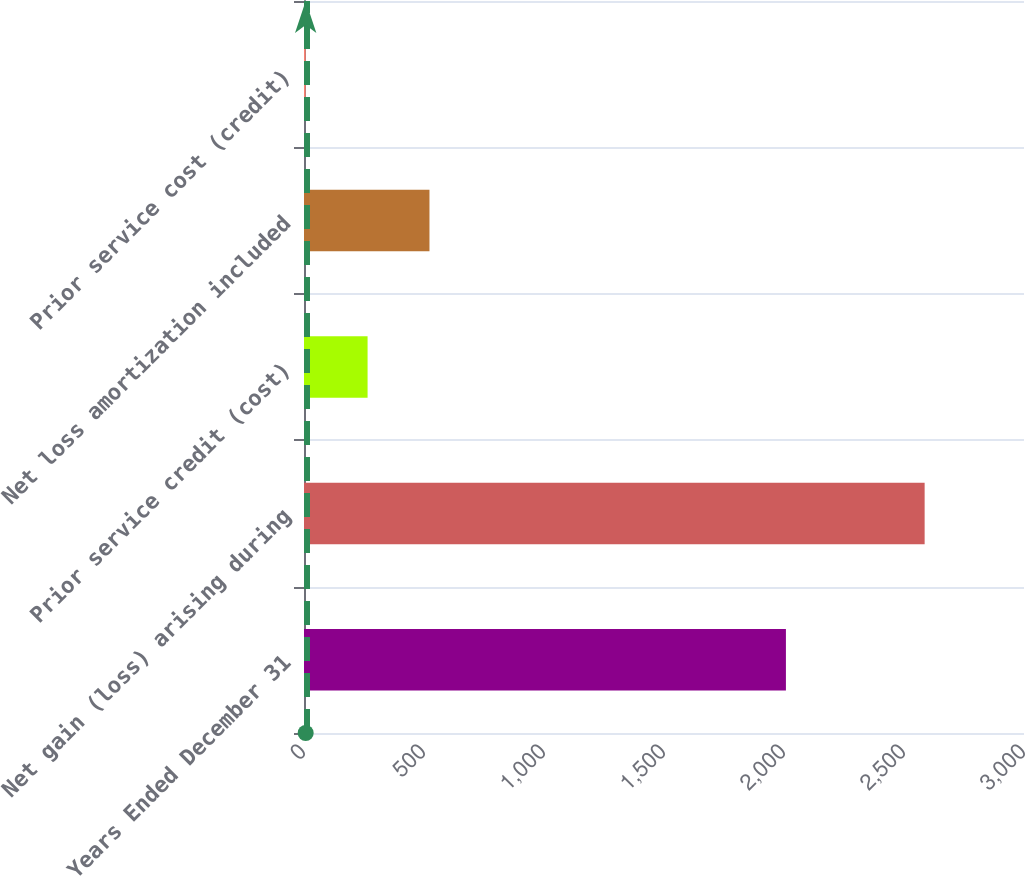Convert chart. <chart><loc_0><loc_0><loc_500><loc_500><bar_chart><fcel>Years Ended December 31<fcel>Net gain (loss) arising during<fcel>Prior service credit (cost)<fcel>Net loss amortization included<fcel>Prior service cost (credit)<nl><fcel>2008<fcel>2586<fcel>264.9<fcel>522.8<fcel>7<nl></chart> 